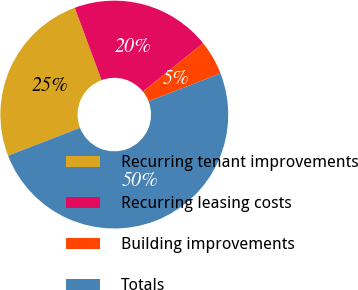Convert chart to OTSL. <chart><loc_0><loc_0><loc_500><loc_500><pie_chart><fcel>Recurring tenant improvements<fcel>Recurring leasing costs<fcel>Building improvements<fcel>Totals<nl><fcel>25.24%<fcel>19.87%<fcel>4.89%<fcel>50.0%<nl></chart> 